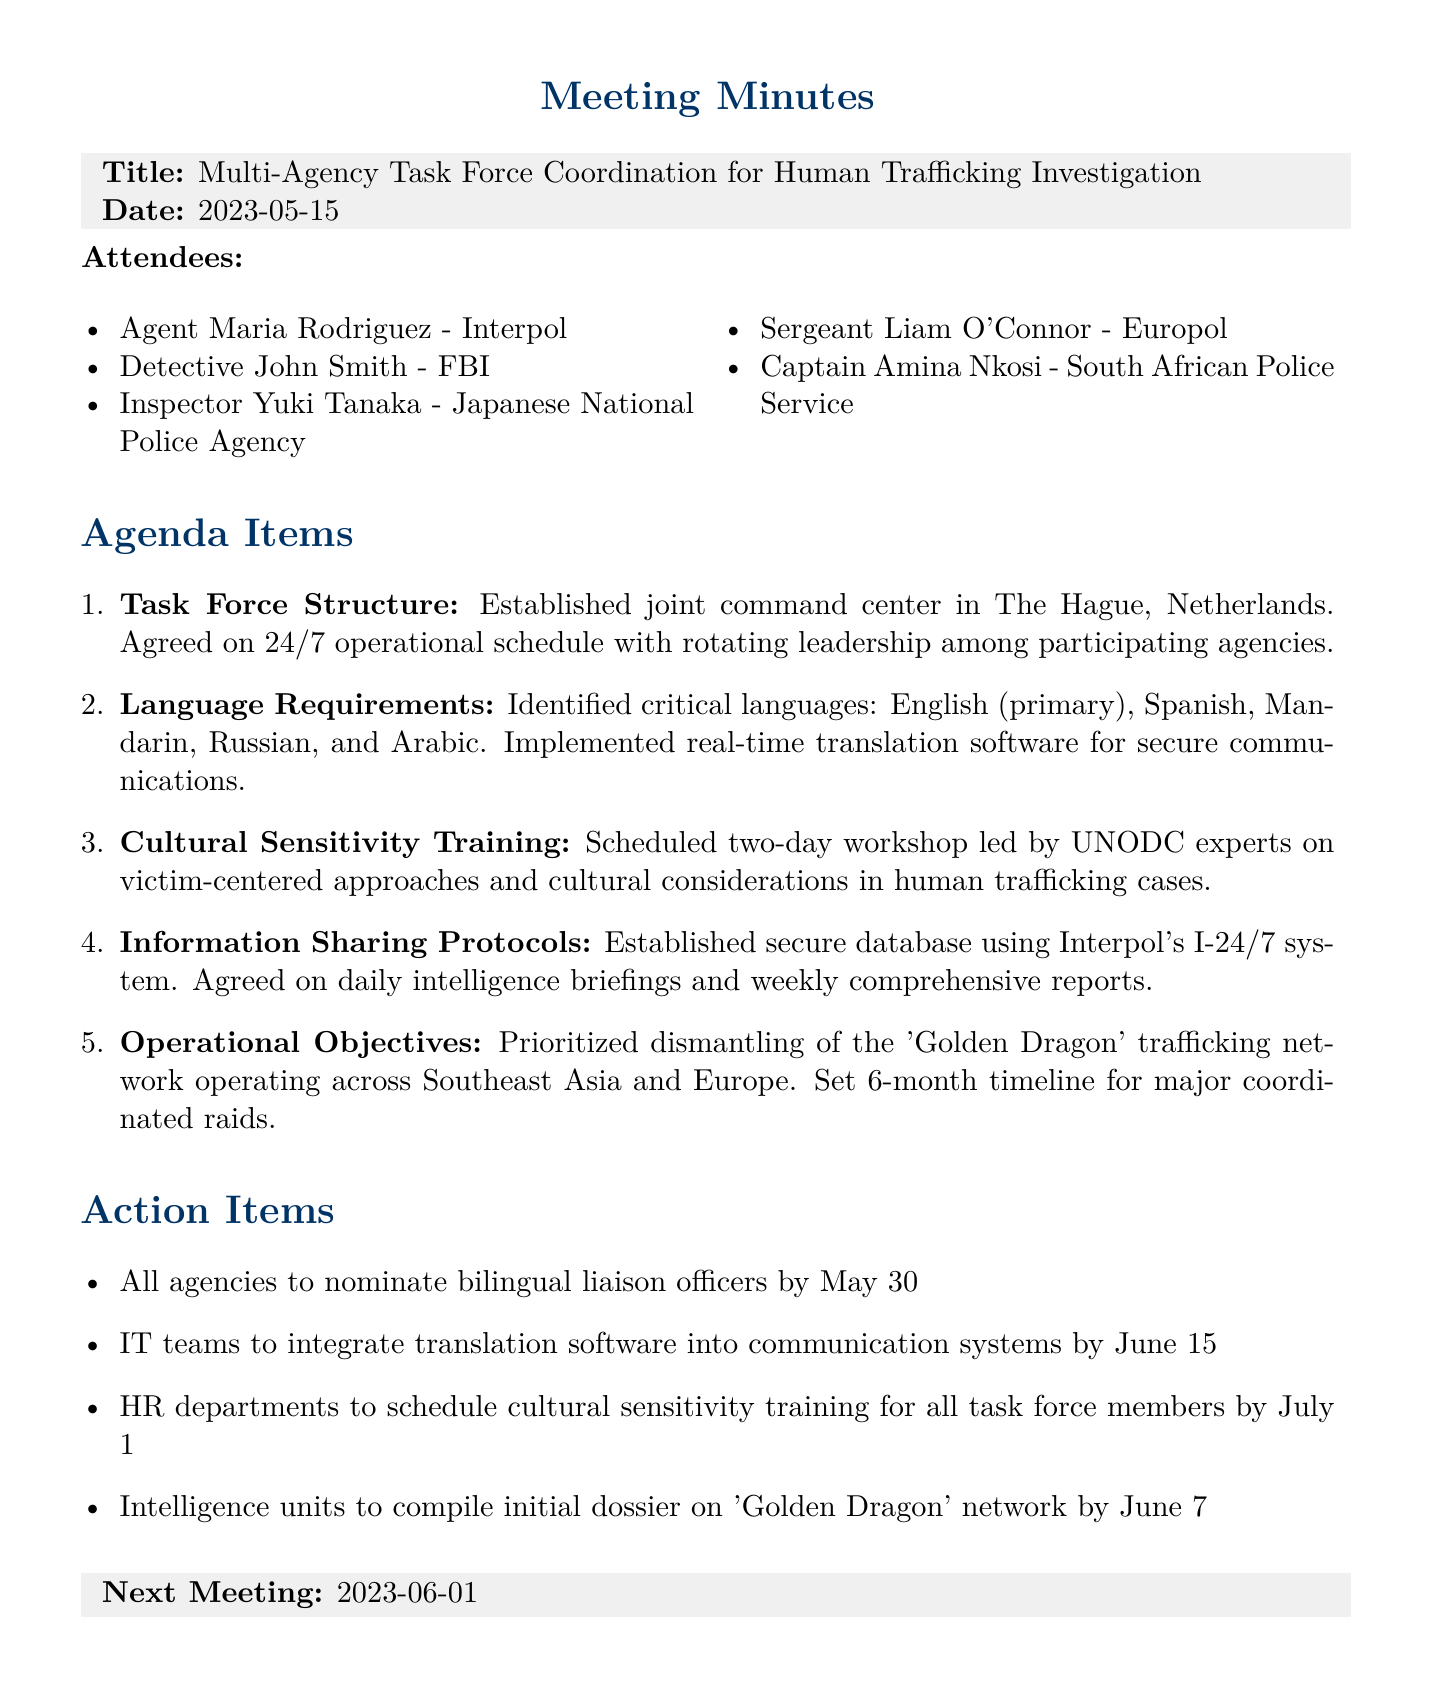What is the meeting title? The title of the meeting is clearly stated at the beginning of the document.
Answer: Multi-Agency Task Force Coordination for Human Trafficking Investigation When is the next meeting scheduled? The next meeting date is specifically mentioned in the document under the next meeting section.
Answer: 2023-06-01 Who is the inspector from the Japanese National Police Agency? The document lists all attendees along with their respective agencies, allowing for easy identification.
Answer: Inspector Yuki Tanaka What languages were identified as critical? The document includes a section outlining the identified critical languages required for the task force.
Answer: English, Spanish, Mandarin, Russian, and Arabic When is the deadline for agencies to nominate bilingual liaison officers? This information is part of the action items listed towards the end of the document.
Answer: May 30 What organization is leading the cultural sensitivity training workshop? The document specifies the organization responsible for the training in the agenda item about cultural sensitivity.
Answer: UNODC What is the primary operational objective of the task force? The operational objectives focus on a specific trafficking network mentioned in the document.
Answer: Dismantling of the 'Golden Dragon' trafficking network What system is used for information sharing among the agencies? The document details the secure database setup for sharing information, indicating the systems in place.
Answer: Interpol's I-24/7 system What is the timeline set for the major coordinated raids? The document states the timeline for operational objectives, which involves major actions to be taken.
Answer: 6-month timeline 